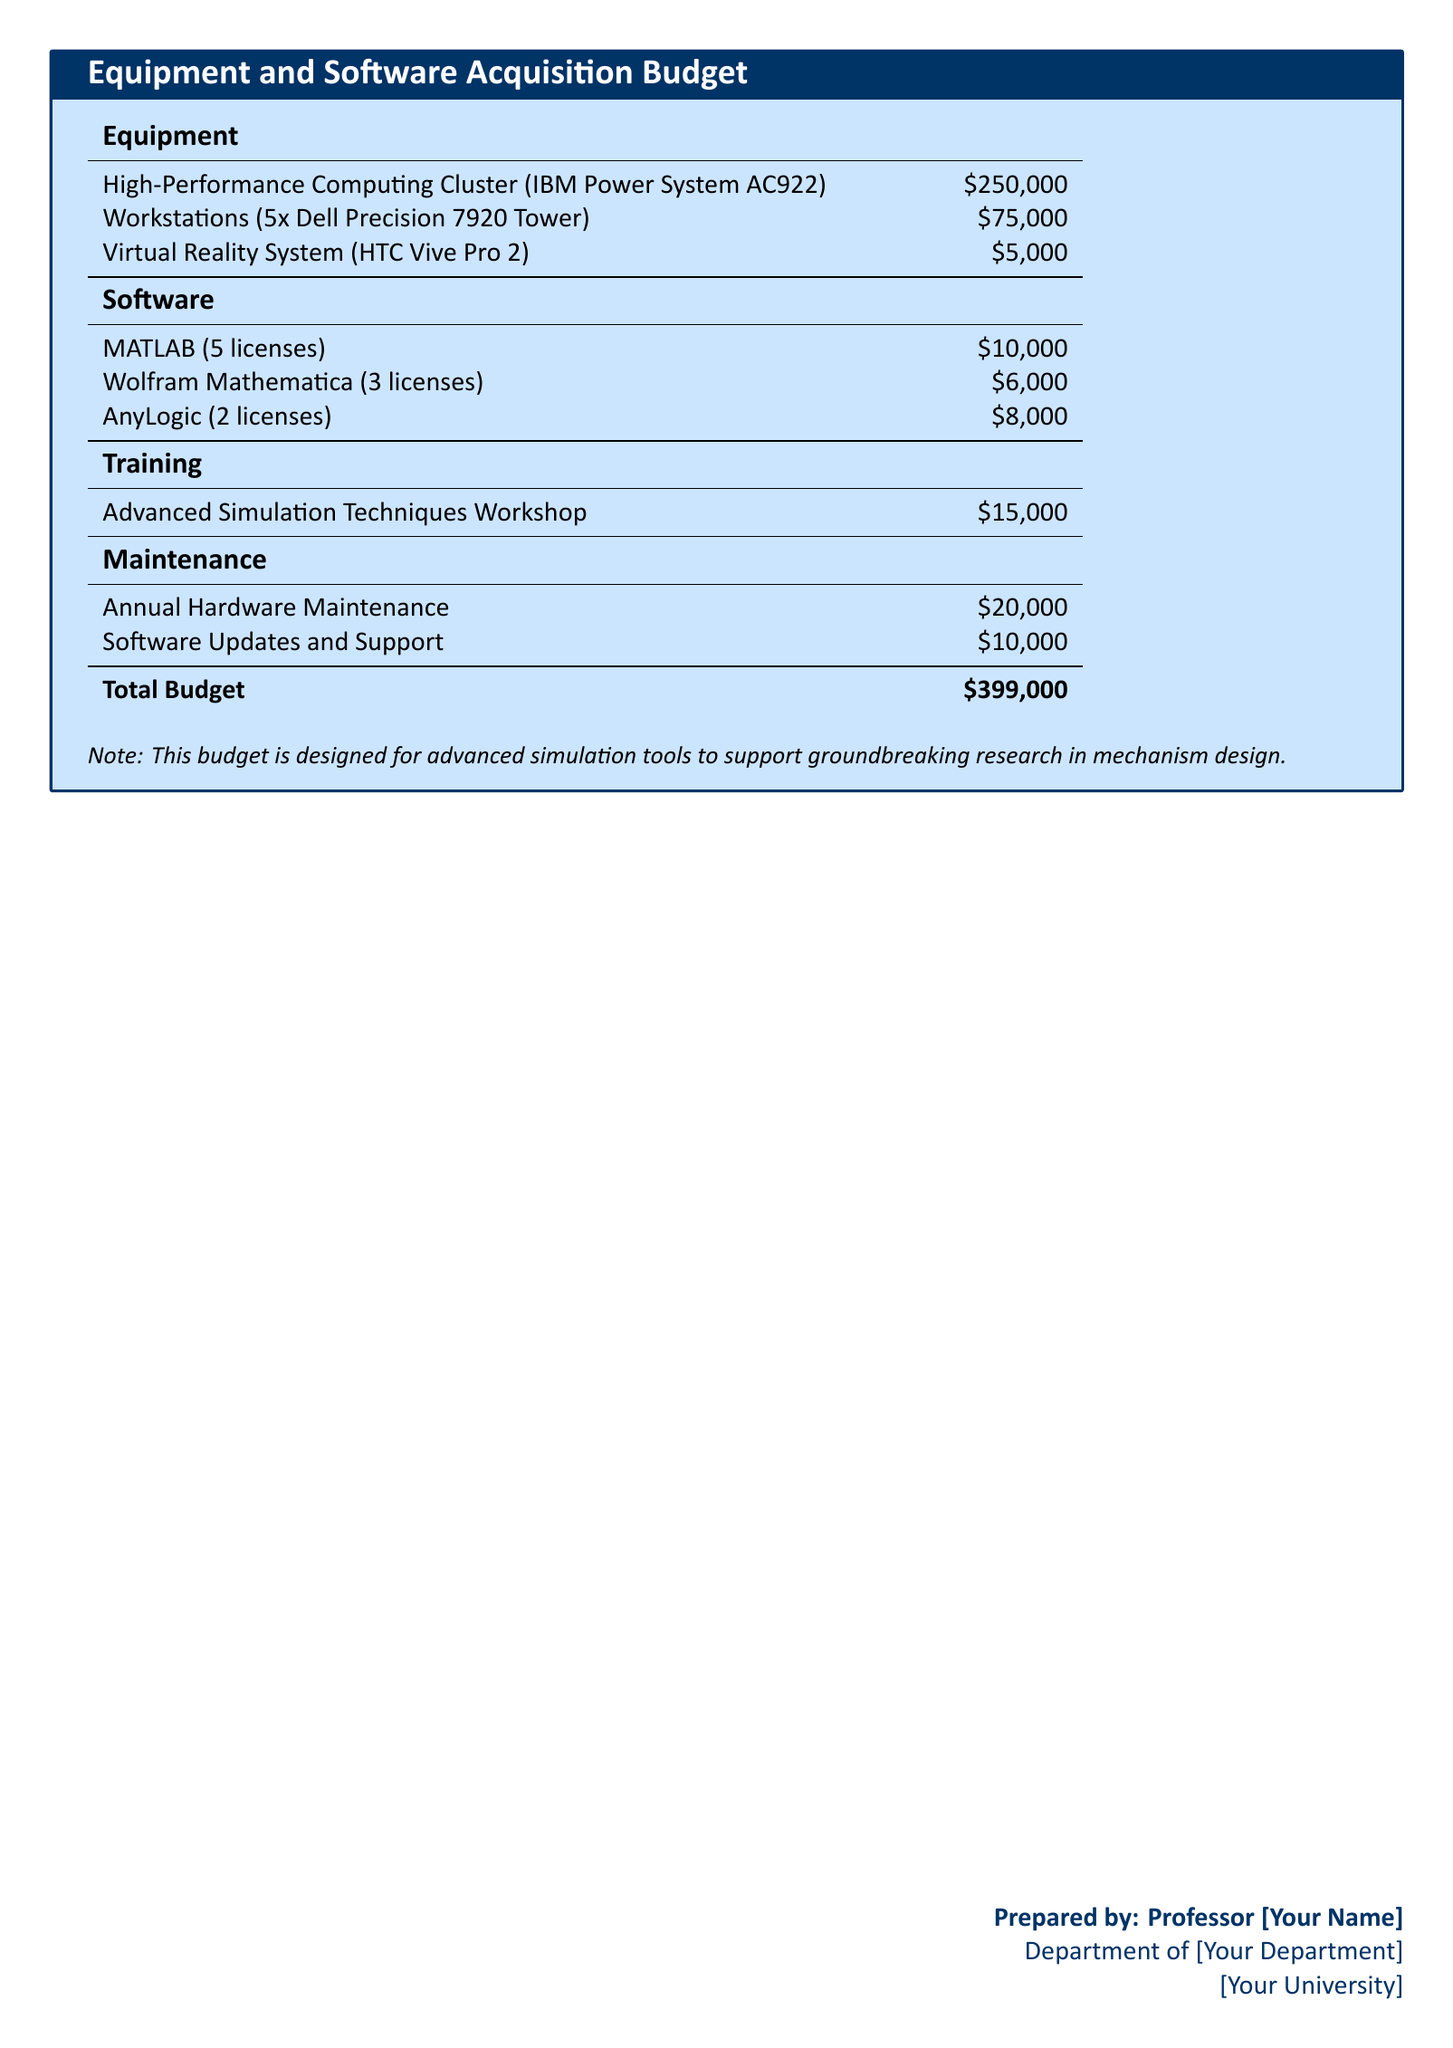What is the total budget? The total budget is provided in the document, summarizing all expenses listed.
Answer: $399,000 How many licenses of MATLAB are included? The document specifies the number of licenses for each software, MATLAB has 5 licenses.
Answer: 5 licenses What is the cost of the High-Performance Computing Cluster? The cost of the High-Performance Computing Cluster is directly stated in the equipment section of the document.
Answer: $250,000 How much is allocated for software updates and support? The document lists software updates and support under the maintenance section, providing a specific amount.
Answer: $10,000 Which virtual reality system is included in the budget? The document names the specific virtual reality system included in the budget.
Answer: HTC Vive Pro 2 What is the cost of the Advanced Simulation Techniques Workshop? The document outlines the budget allocated for training, specifying the amount for this workshop.
Answer: $15,000 How many workstations are being acquired? The document provides the number of workstations in the equipment section.
Answer: 5 What percentage of the total budget is allocated for maintenance? To find this, you can sum maintenance costs and compare it to the total budget stated. Maintenance costs total $30,000. The percentage can be calculated as (30,000 / 399,000) * 100.
Answer: Approximately 7.5% What is the budget allocation for software in total? The software section lists the costs associated with each software, which can be summed.
Answer: $24,000 